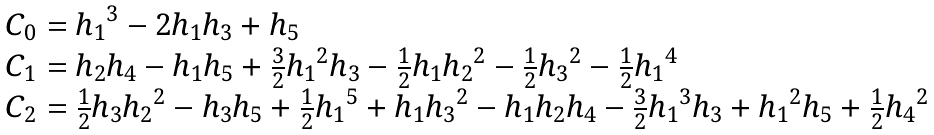Convert formula to latex. <formula><loc_0><loc_0><loc_500><loc_500>\begin{array} { l } C _ { 0 } = { h _ { 1 } } ^ { 3 } - 2 h _ { 1 } h _ { 3 } + h _ { 5 } \\ C _ { 1 } = h _ { 2 } h _ { 4 } - h _ { 1 } h _ { 5 } + \frac { 3 } { 2 } { h _ { 1 } } ^ { 2 } h _ { 3 } - \frac { 1 } { 2 } h _ { 1 } { h _ { 2 } } ^ { 2 } - \frac { 1 } { 2 } { h _ { 3 } } ^ { 2 } - \frac { 1 } { 2 } { h _ { 1 } } ^ { 4 } \\ C _ { 2 } = \frac { 1 } { 2 } h _ { 3 } { h _ { 2 } } ^ { 2 } - h _ { 3 } h _ { 5 } + \frac { 1 } { 2 } { h _ { 1 } } ^ { 5 } + h _ { 1 } { h _ { 3 } } ^ { 2 } - h _ { 1 } h _ { 2 } h _ { 4 } - \frac { 3 } { 2 } { h _ { 1 } } ^ { 3 } h _ { 3 } + { h _ { 1 } } ^ { 2 } h _ { 5 } + \frac { 1 } { 2 } { h _ { 4 } } ^ { 2 } \end{array}</formula> 